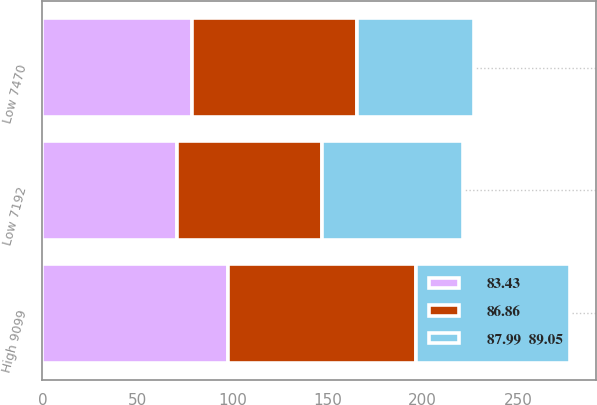<chart> <loc_0><loc_0><loc_500><loc_500><stacked_bar_chart><ecel><fcel>Low 7192<fcel>High 9099<fcel>Low 7470<nl><fcel>86.86<fcel>76.51<fcel>99.24<fcel>86.91<nl><fcel>83.43<fcel>70.59<fcel>97.39<fcel>78.51<nl><fcel>87.99  89.05<fcel>73.81<fcel>80.82<fcel>61.72<nl></chart> 